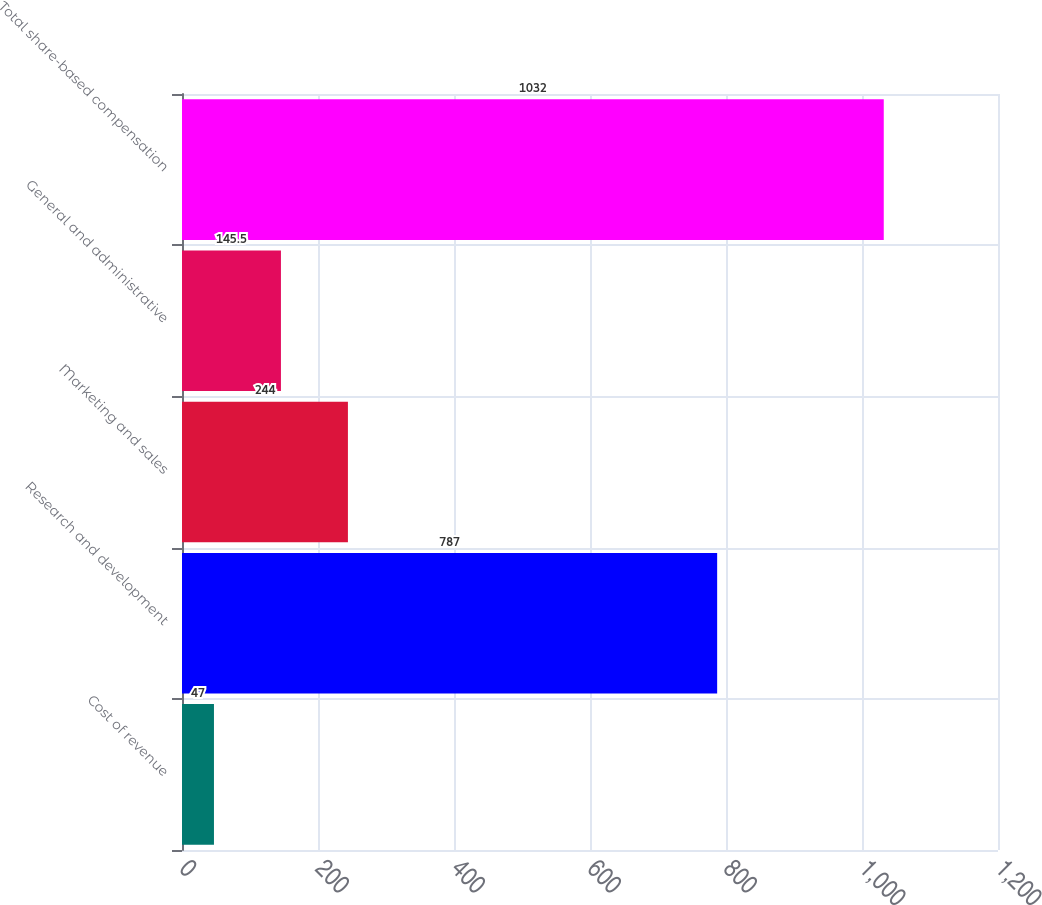Convert chart. <chart><loc_0><loc_0><loc_500><loc_500><bar_chart><fcel>Cost of revenue<fcel>Research and development<fcel>Marketing and sales<fcel>General and administrative<fcel>Total share-based compensation<nl><fcel>47<fcel>787<fcel>244<fcel>145.5<fcel>1032<nl></chart> 